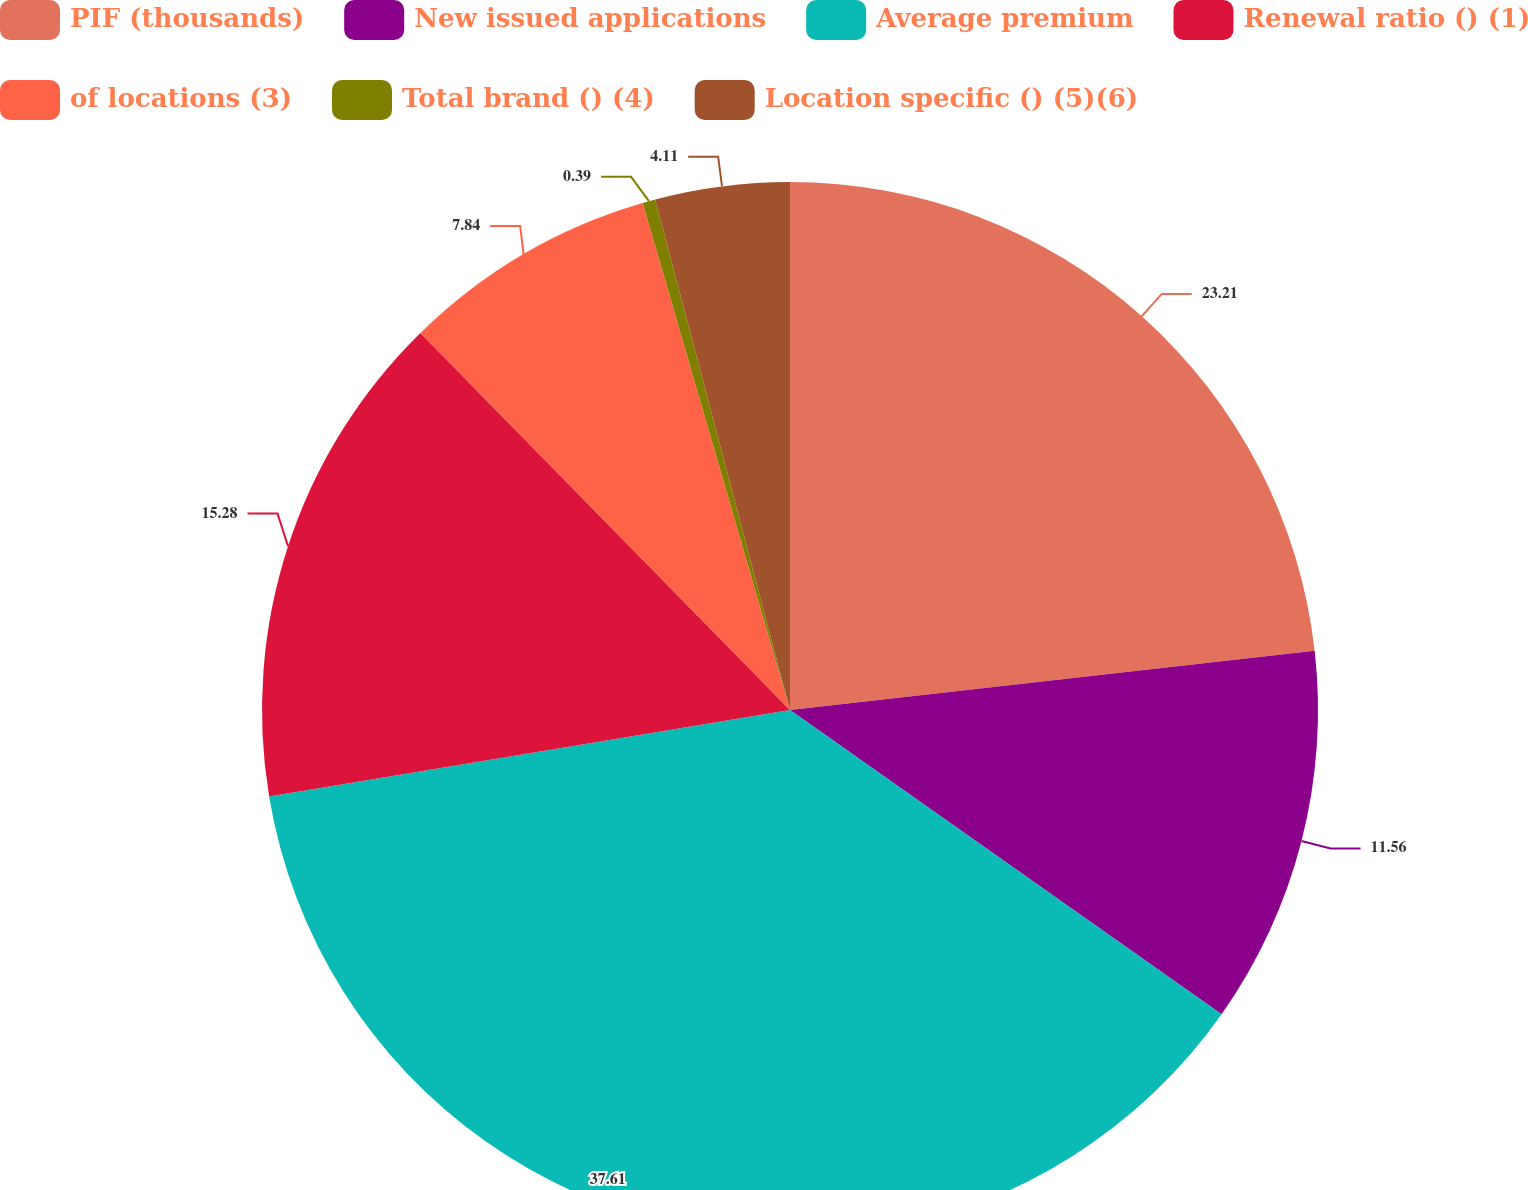Convert chart to OTSL. <chart><loc_0><loc_0><loc_500><loc_500><pie_chart><fcel>PIF (thousands)<fcel>New issued applications<fcel>Average premium<fcel>Renewal ratio () (1)<fcel>of locations (3)<fcel>Total brand () (4)<fcel>Location specific () (5)(6)<nl><fcel>23.21%<fcel>11.56%<fcel>37.61%<fcel>15.28%<fcel>7.84%<fcel>0.39%<fcel>4.11%<nl></chart> 